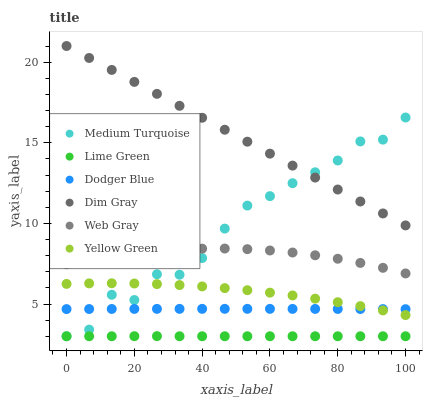Does Lime Green have the minimum area under the curve?
Answer yes or no. Yes. Does Dim Gray have the maximum area under the curve?
Answer yes or no. Yes. Does Yellow Green have the minimum area under the curve?
Answer yes or no. No. Does Yellow Green have the maximum area under the curve?
Answer yes or no. No. Is Dim Gray the smoothest?
Answer yes or no. Yes. Is Medium Turquoise the roughest?
Answer yes or no. Yes. Is Yellow Green the smoothest?
Answer yes or no. No. Is Yellow Green the roughest?
Answer yes or no. No. Does Medium Turquoise have the lowest value?
Answer yes or no. Yes. Does Yellow Green have the lowest value?
Answer yes or no. No. Does Dim Gray have the highest value?
Answer yes or no. Yes. Does Yellow Green have the highest value?
Answer yes or no. No. Is Lime Green less than Web Gray?
Answer yes or no. Yes. Is Web Gray greater than Yellow Green?
Answer yes or no. Yes. Does Medium Turquoise intersect Dodger Blue?
Answer yes or no. Yes. Is Medium Turquoise less than Dodger Blue?
Answer yes or no. No. Is Medium Turquoise greater than Dodger Blue?
Answer yes or no. No. Does Lime Green intersect Web Gray?
Answer yes or no. No. 